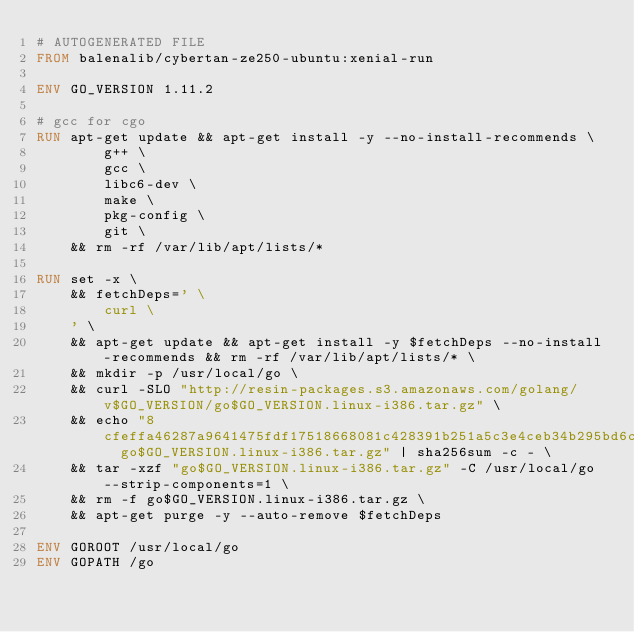<code> <loc_0><loc_0><loc_500><loc_500><_Dockerfile_># AUTOGENERATED FILE
FROM balenalib/cybertan-ze250-ubuntu:xenial-run

ENV GO_VERSION 1.11.2

# gcc for cgo
RUN apt-get update && apt-get install -y --no-install-recommends \
		g++ \
		gcc \
		libc6-dev \
		make \
		pkg-config \
		git \
	&& rm -rf /var/lib/apt/lists/*

RUN set -x \
	&& fetchDeps=' \
		curl \
	' \
	&& apt-get update && apt-get install -y $fetchDeps --no-install-recommends && rm -rf /var/lib/apt/lists/* \
	&& mkdir -p /usr/local/go \
	&& curl -SLO "http://resin-packages.s3.amazonaws.com/golang/v$GO_VERSION/go$GO_VERSION.linux-i386.tar.gz" \
	&& echo "8cfeffa46287a9641475fdf17518668081c428391b251a5c3e4ceb34b295bd6c  go$GO_VERSION.linux-i386.tar.gz" | sha256sum -c - \
	&& tar -xzf "go$GO_VERSION.linux-i386.tar.gz" -C /usr/local/go --strip-components=1 \
	&& rm -f go$GO_VERSION.linux-i386.tar.gz \
	&& apt-get purge -y --auto-remove $fetchDeps

ENV GOROOT /usr/local/go
ENV GOPATH /go</code> 